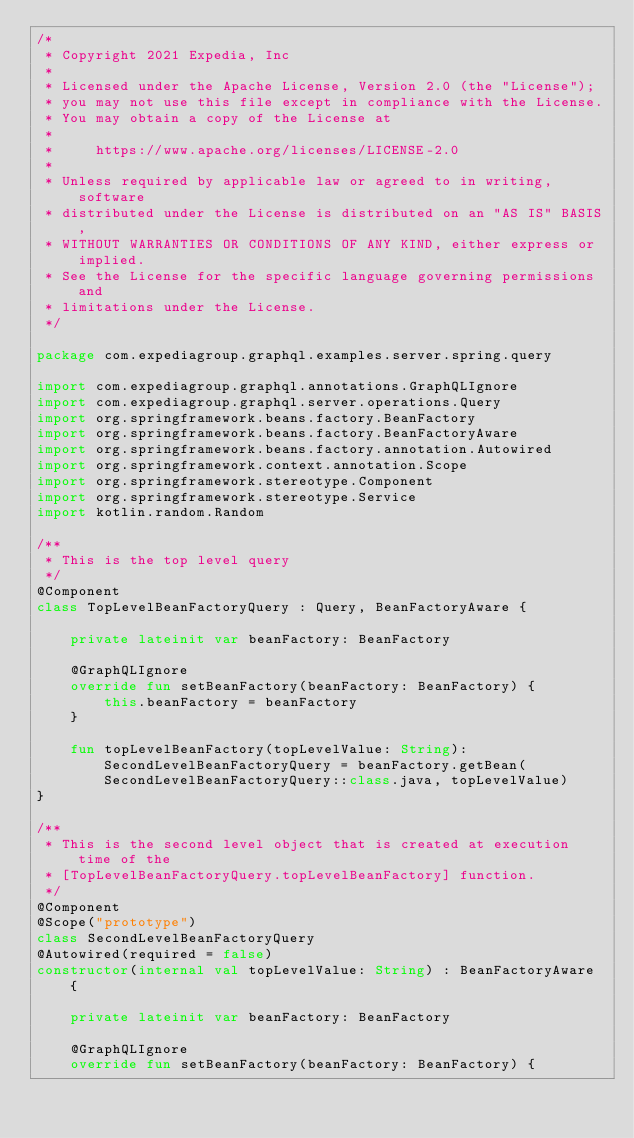Convert code to text. <code><loc_0><loc_0><loc_500><loc_500><_Kotlin_>/*
 * Copyright 2021 Expedia, Inc
 *
 * Licensed under the Apache License, Version 2.0 (the "License");
 * you may not use this file except in compliance with the License.
 * You may obtain a copy of the License at
 *
 *     https://www.apache.org/licenses/LICENSE-2.0
 *
 * Unless required by applicable law or agreed to in writing, software
 * distributed under the License is distributed on an "AS IS" BASIS,
 * WITHOUT WARRANTIES OR CONDITIONS OF ANY KIND, either express or implied.
 * See the License for the specific language governing permissions and
 * limitations under the License.
 */

package com.expediagroup.graphql.examples.server.spring.query

import com.expediagroup.graphql.annotations.GraphQLIgnore
import com.expediagroup.graphql.server.operations.Query
import org.springframework.beans.factory.BeanFactory
import org.springframework.beans.factory.BeanFactoryAware
import org.springframework.beans.factory.annotation.Autowired
import org.springframework.context.annotation.Scope
import org.springframework.stereotype.Component
import org.springframework.stereotype.Service
import kotlin.random.Random

/**
 * This is the top level query
 */
@Component
class TopLevelBeanFactoryQuery : Query, BeanFactoryAware {

    private lateinit var beanFactory: BeanFactory

    @GraphQLIgnore
    override fun setBeanFactory(beanFactory: BeanFactory) {
        this.beanFactory = beanFactory
    }

    fun topLevelBeanFactory(topLevelValue: String): SecondLevelBeanFactoryQuery = beanFactory.getBean(SecondLevelBeanFactoryQuery::class.java, topLevelValue)
}

/**
 * This is the second level object that is created at execution time of the
 * [TopLevelBeanFactoryQuery.topLevelBeanFactory] function.
 */
@Component
@Scope("prototype")
class SecondLevelBeanFactoryQuery
@Autowired(required = false)
constructor(internal val topLevelValue: String) : BeanFactoryAware {

    private lateinit var beanFactory: BeanFactory

    @GraphQLIgnore
    override fun setBeanFactory(beanFactory: BeanFactory) {</code> 